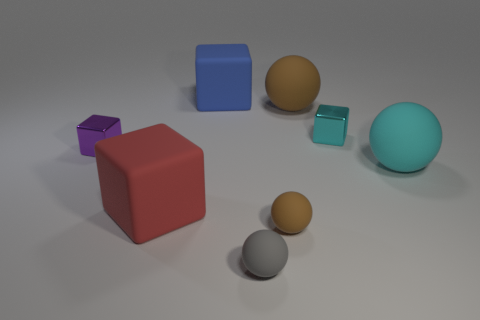Add 1 red shiny cylinders. How many objects exist? 9 Add 3 tiny purple blocks. How many tiny purple blocks exist? 4 Subtract 0 gray cylinders. How many objects are left? 8 Subtract all small yellow cylinders. Subtract all small metallic things. How many objects are left? 6 Add 4 small gray matte objects. How many small gray matte objects are left? 5 